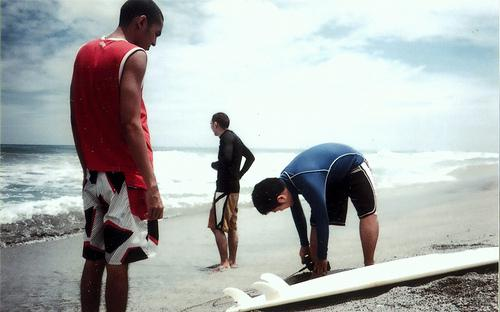Question: how many people are in the picture?
Choices:
A. One.
B. Two.
C. Four.
D. Three.
Answer with the letter. Answer: D Question: where are the people?
Choices:
A. At a baseball game.
B. At the beach.
C. At home.
D. At a party.
Answer with the letter. Answer: B Question: what are the people standing on?
Choices:
A. Grass.
B. Asphalt.
C. Carpet.
D. Sand.
Answer with the letter. Answer: D 